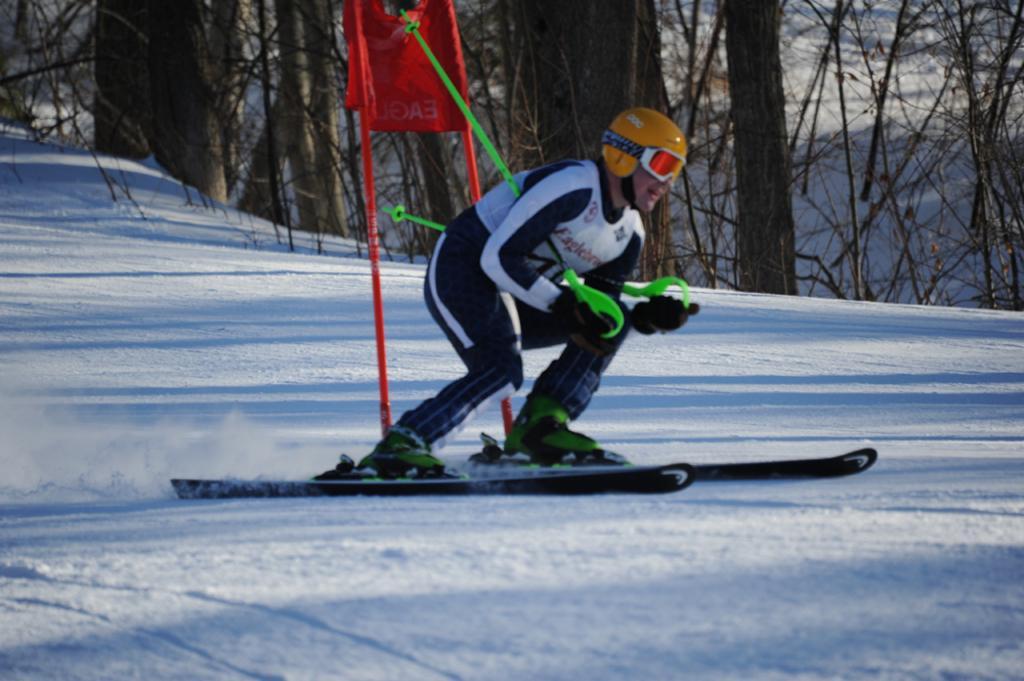How would you summarize this image in a sentence or two? In this image we can see a person doing ice skating wearing helmet, goggles and holding two sticks, behind him we can see a few trees and a stand. 